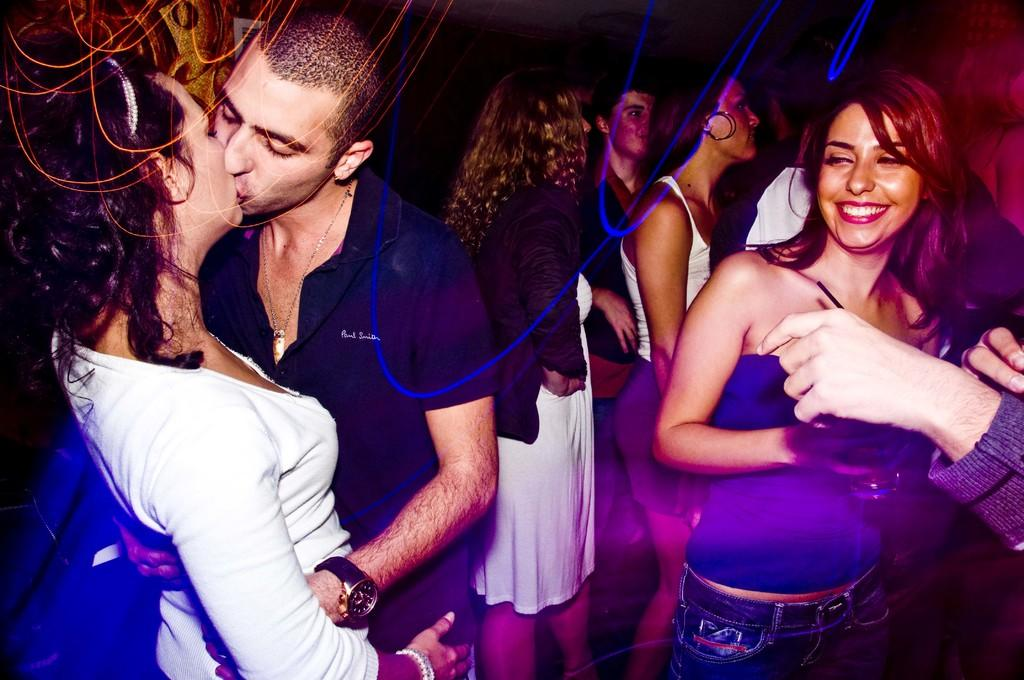What can be observed about the people in the image? There are people standing in the image, including women and a man. Can you describe the background of the image? The background of the image is dark. What additional detail is present in the image? Blue color lines are visible in the image. How many sisters are present in the image? There is no mention of sisters in the image, so it cannot be determined how many there are. What type of pan is being used by the people in the image? There is no pan visible in the image. 